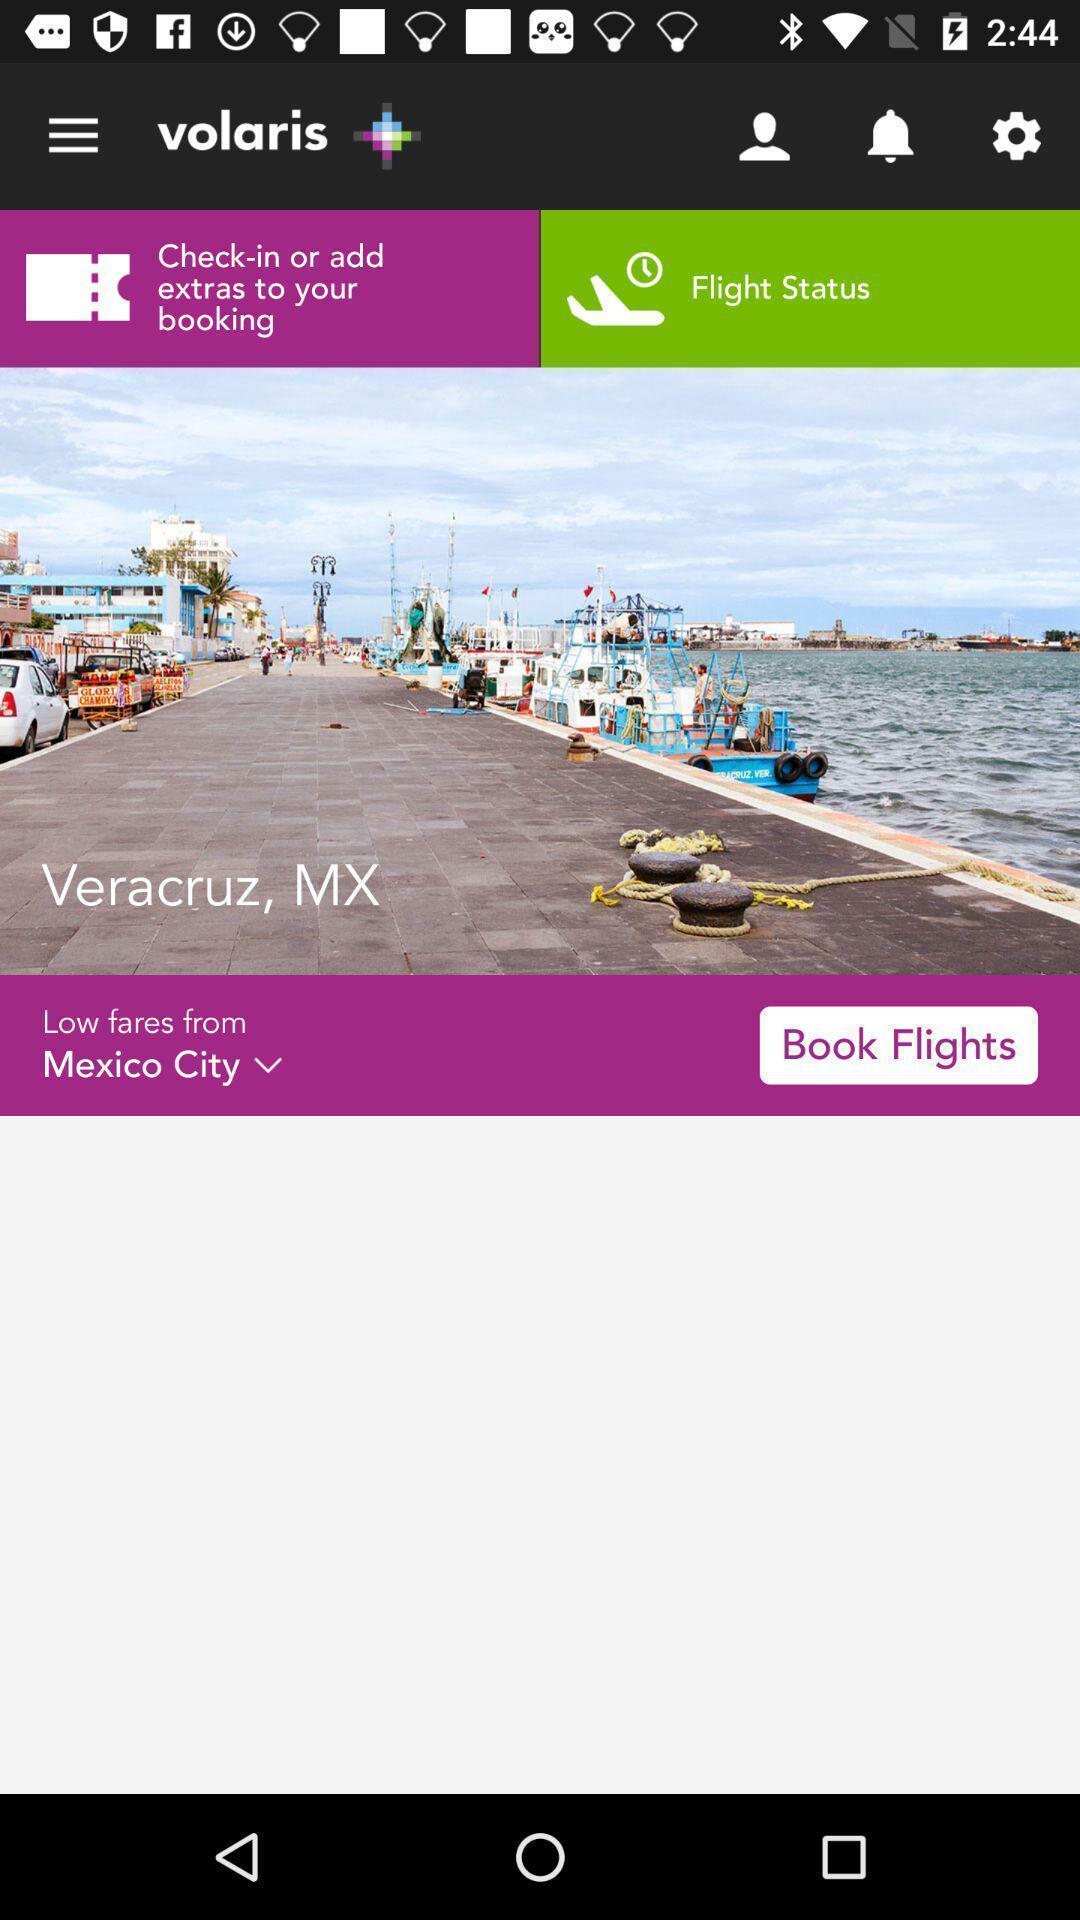Describe the content in this image. Page showing book flights. 